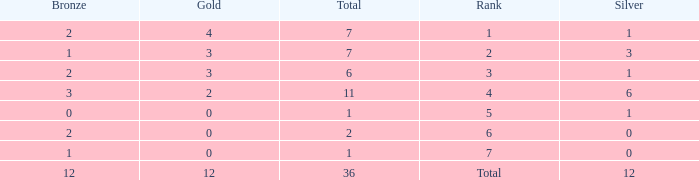What is the largest total for a team with fewer than 12 bronze, 1 silver and 0 gold medals? 1.0. 